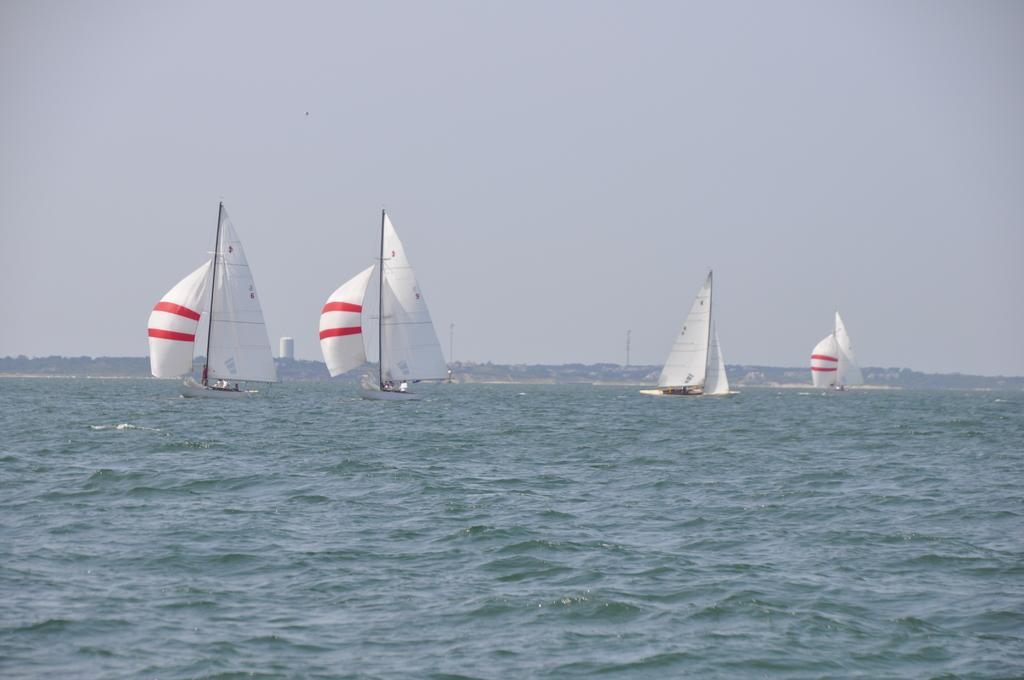How many people are in the image? There is a group of people in the image. What are the people doing in the image? The people are in boats. What is visible in the image besides the people and boats? There is water, trees, towers, buildings, and the sky visible in the image. Where might this image have been taken? The image may have been taken in the ocean. What type of yak can be seen in the image? There is no yak present in the image. What is the purpose of the tub in the image? There is no tub present in the image. 